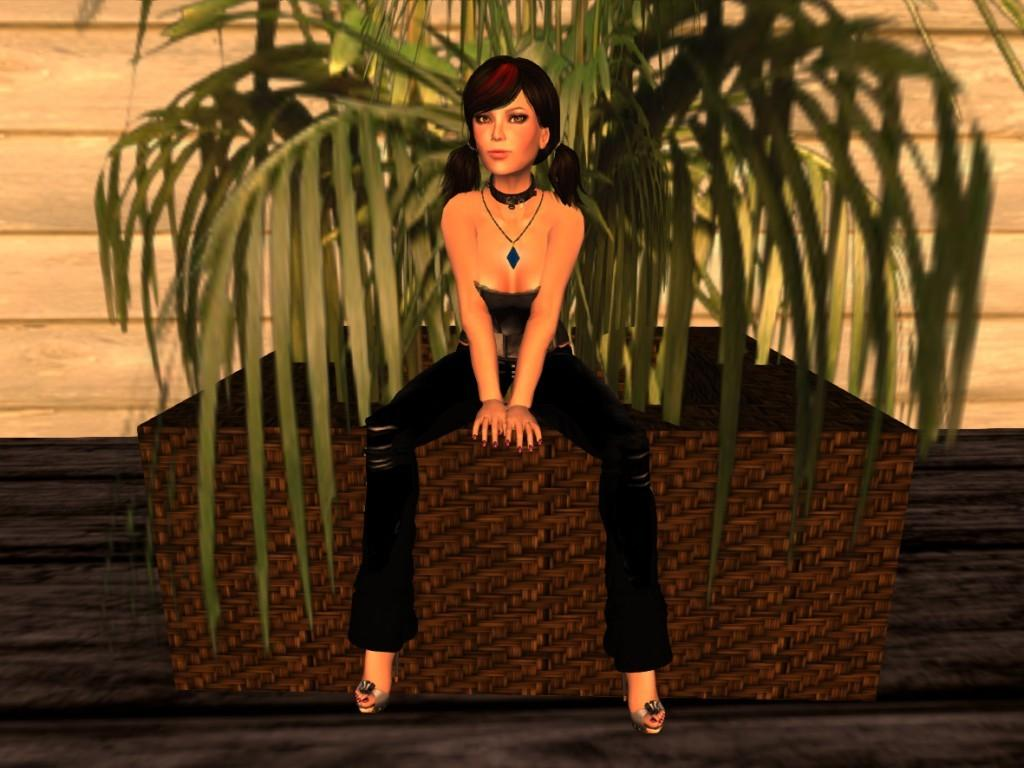Who is present in the image? There is a woman in the image. What object can be seen near the woman? There is a plant pot in the image. What is the background of the image? There is a wall in the image. What type of image is this? The image is animated. What type of flower is growing in the egg in the image? There is no egg or flower present in the image. 